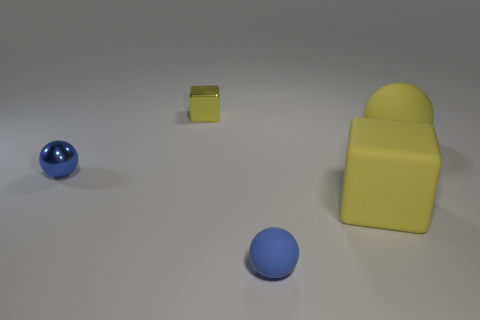Subtract all blue blocks. How many blue balls are left? 2 Add 2 blue rubber objects. How many objects exist? 7 Subtract all cubes. How many objects are left? 3 Subtract all large blocks. Subtract all tiny cyan rubber blocks. How many objects are left? 4 Add 3 yellow metallic things. How many yellow metallic things are left? 4 Add 4 tiny rubber spheres. How many tiny rubber spheres exist? 5 Subtract 0 blue blocks. How many objects are left? 5 